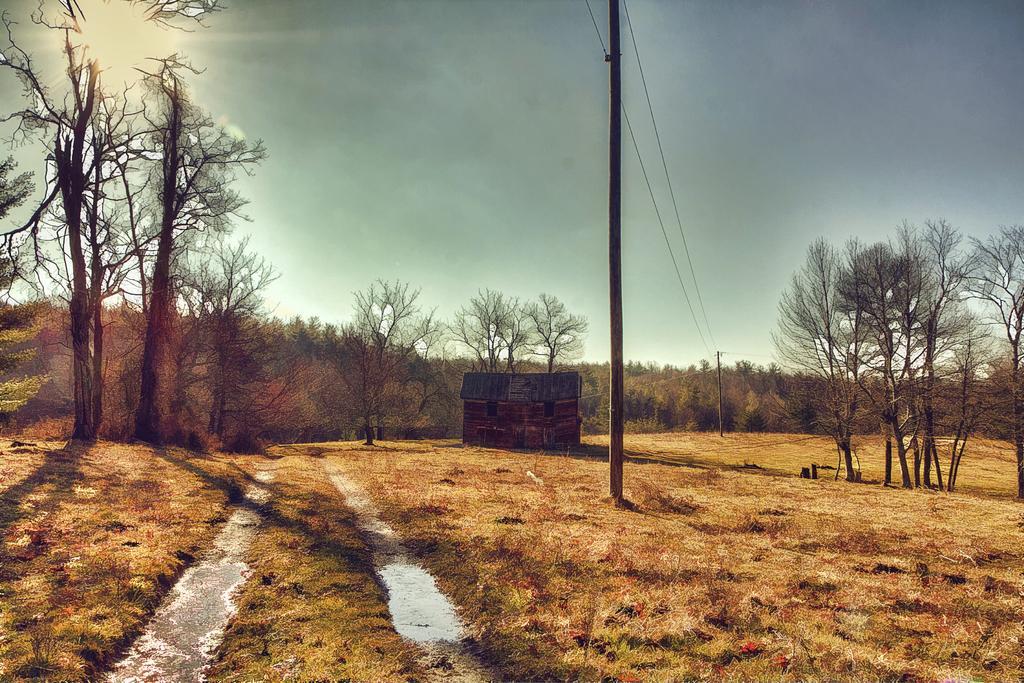Please provide a concise description of this image. In this image I can see few electric poles. I can also see a house, background I can see few dried trees and few trees in green color and the sky is in white and blue color. 